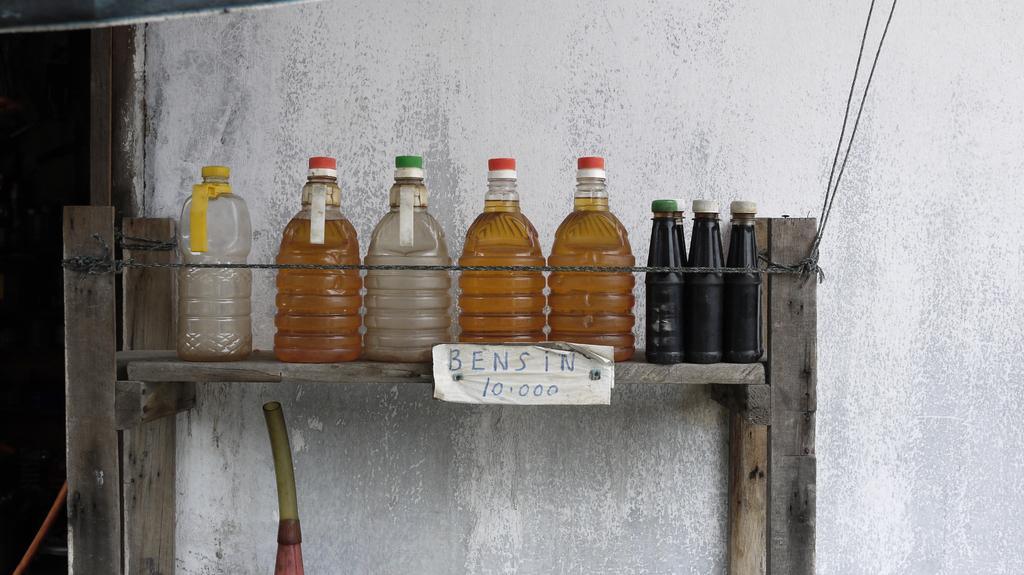Could you give a brief overview of what you see in this image? Here we can see various types of bottles with some liquid present in it placed on wooden rack and below there is a pipe and there is some thing written on the paper 